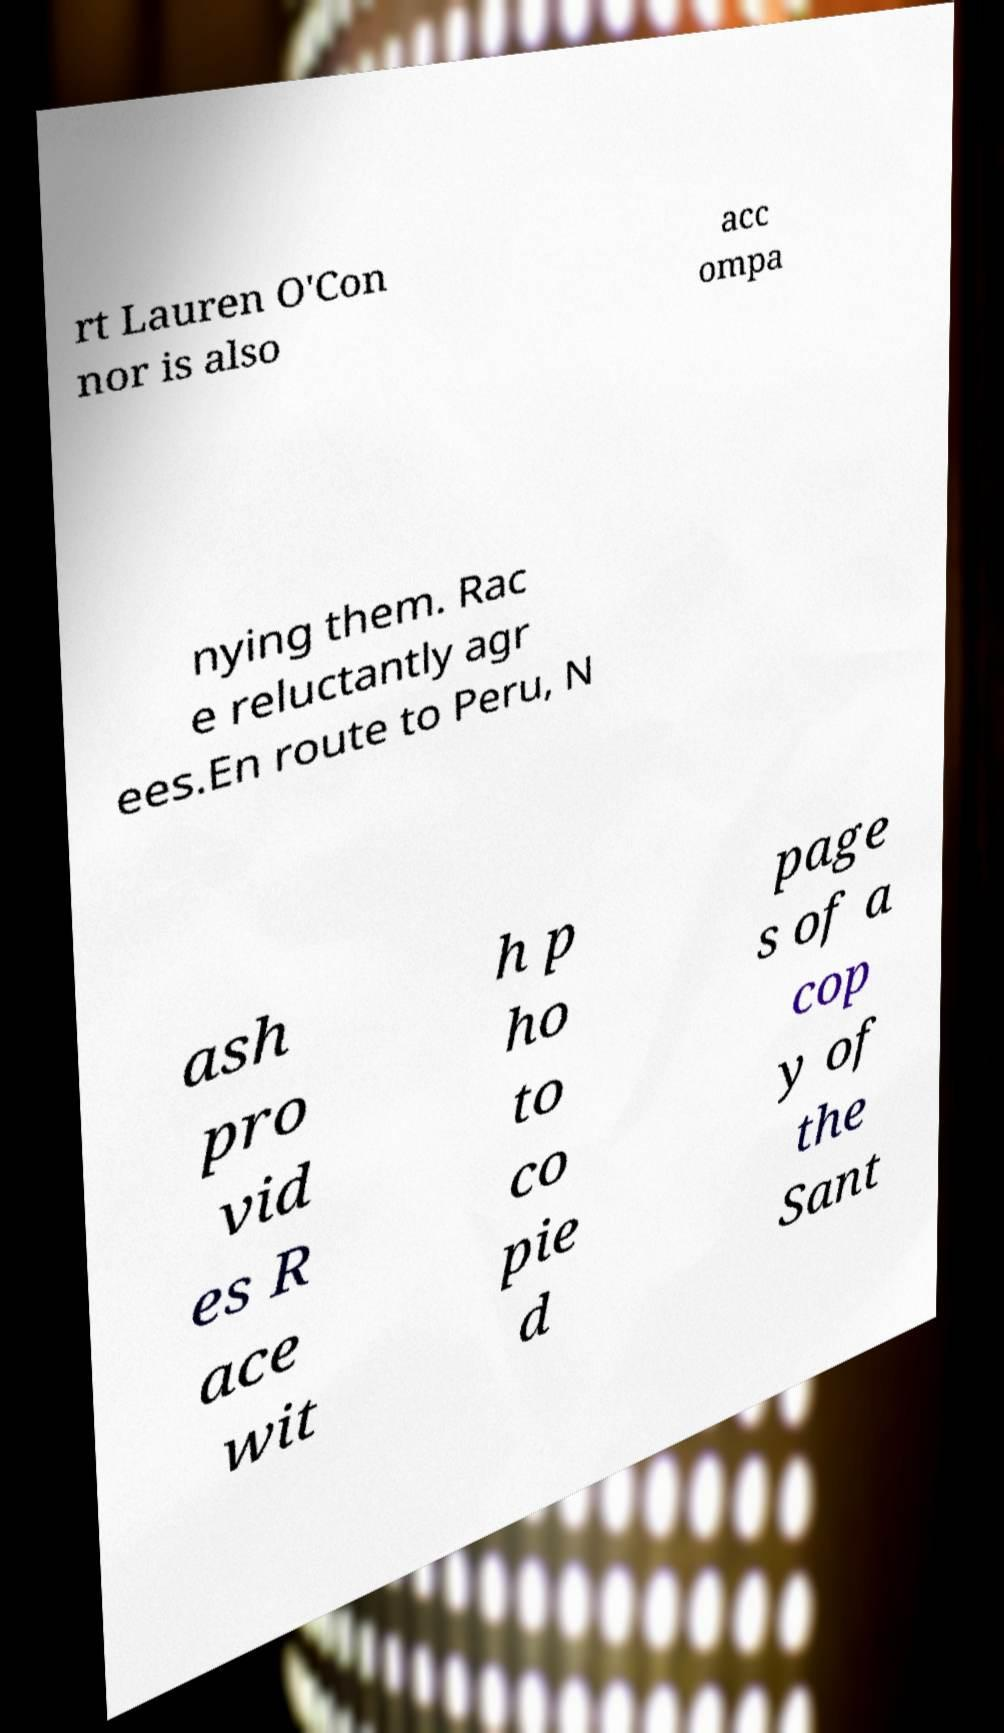Could you extract and type out the text from this image? rt Lauren O'Con nor is also acc ompa nying them. Rac e reluctantly agr ees.En route to Peru, N ash pro vid es R ace wit h p ho to co pie d page s of a cop y of the Sant 